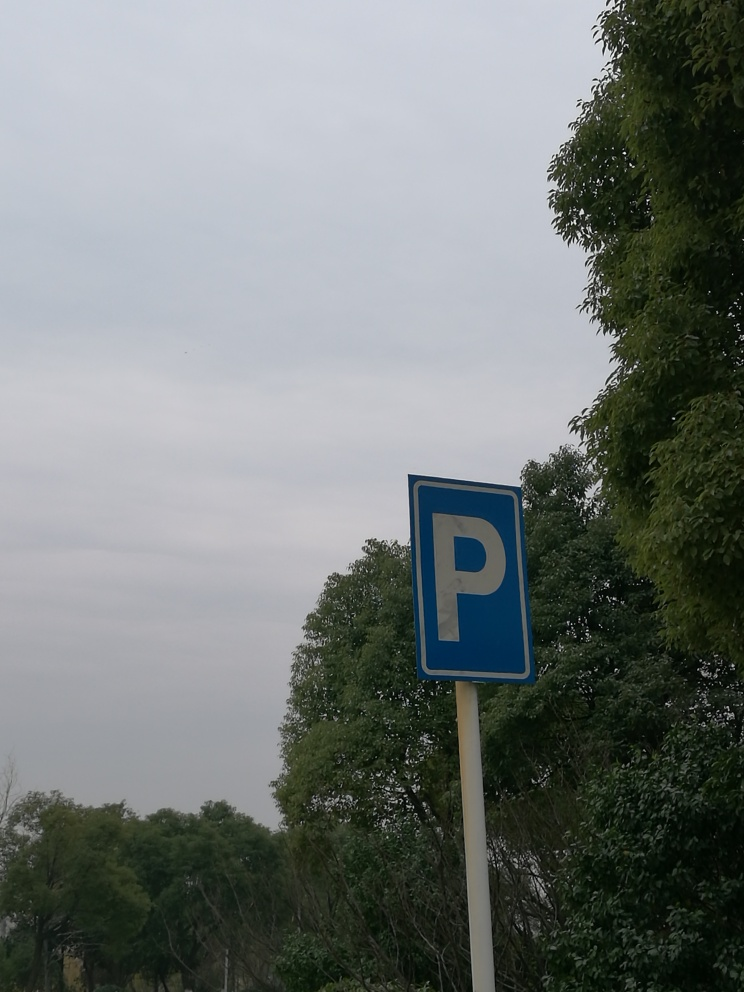Describe the weather or the time of day the photo was taken based on the lighting and environment. The overcast sky suggests it might be a cloudy day, which could indicate either early morning or late afternoon hours when sunlight is not evident. The absence of shadows due to diffuse lighting makes it complex to pinpoint the exact time of day with certainty. Can you estimate the season by looking at the trees? The trees are lush and fully leafed, which would generally suggest late spring through summer, as these seasons are characterized by vibrant foliage. 